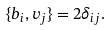Convert formula to latex. <formula><loc_0><loc_0><loc_500><loc_500>\{ b _ { i } , v _ { j } \} = 2 \delta _ { i j } .</formula> 